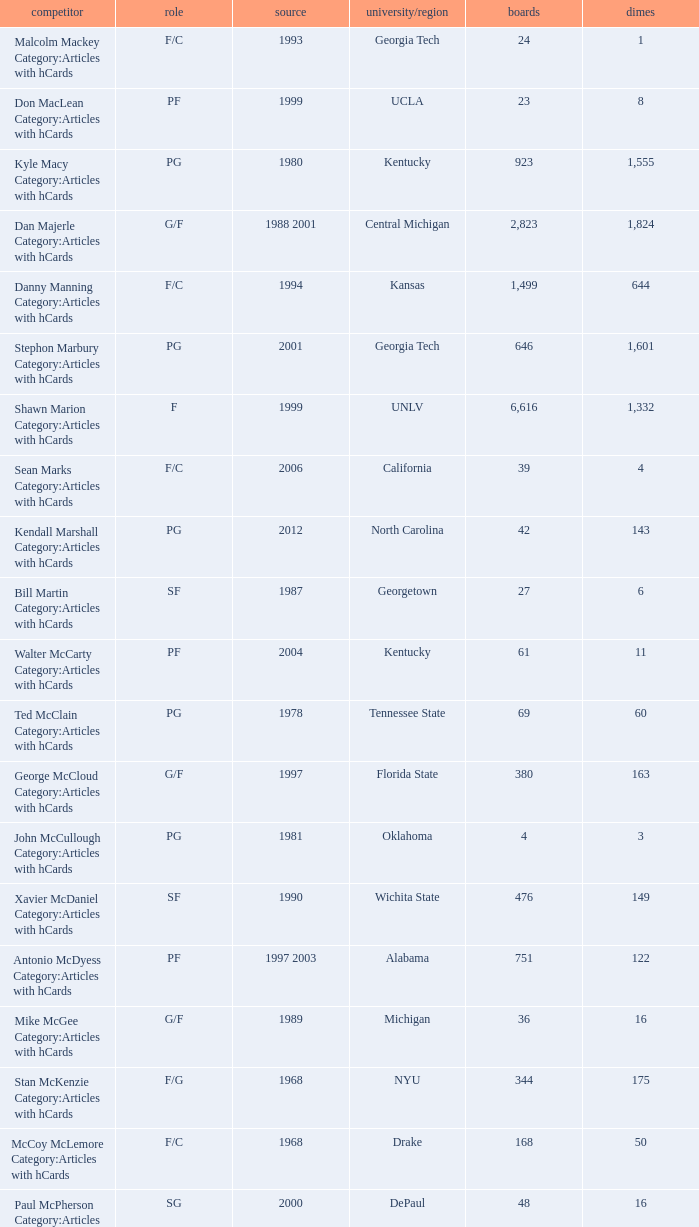What position does the player from arkansas play? C. 